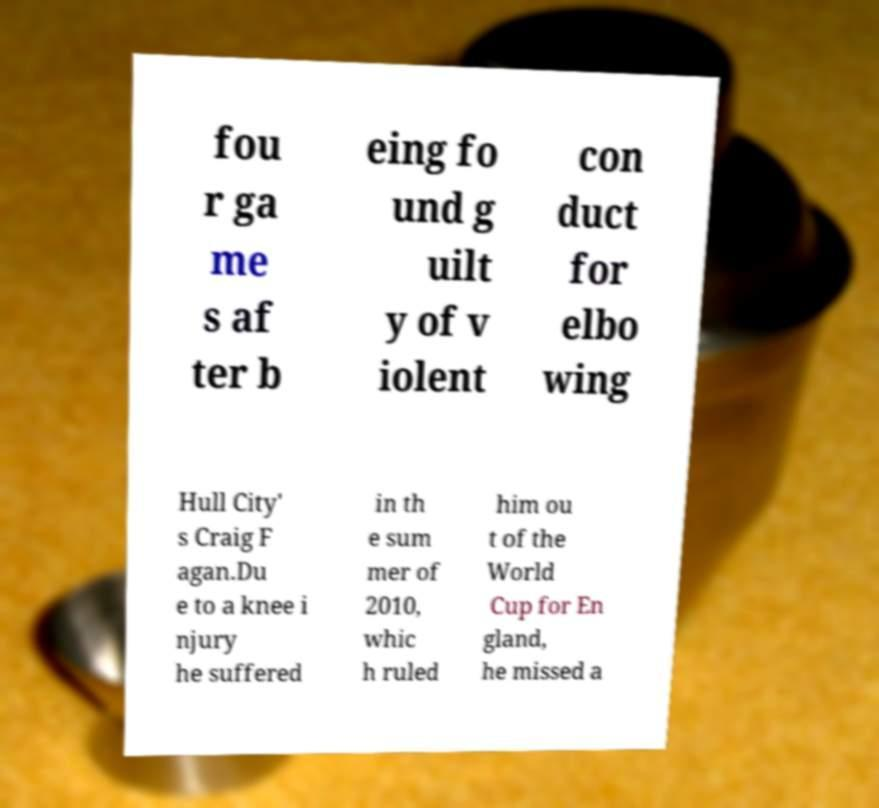What messages or text are displayed in this image? I need them in a readable, typed format. fou r ga me s af ter b eing fo und g uilt y of v iolent con duct for elbo wing Hull City' s Craig F agan.Du e to a knee i njury he suffered in th e sum mer of 2010, whic h ruled him ou t of the World Cup for En gland, he missed a 